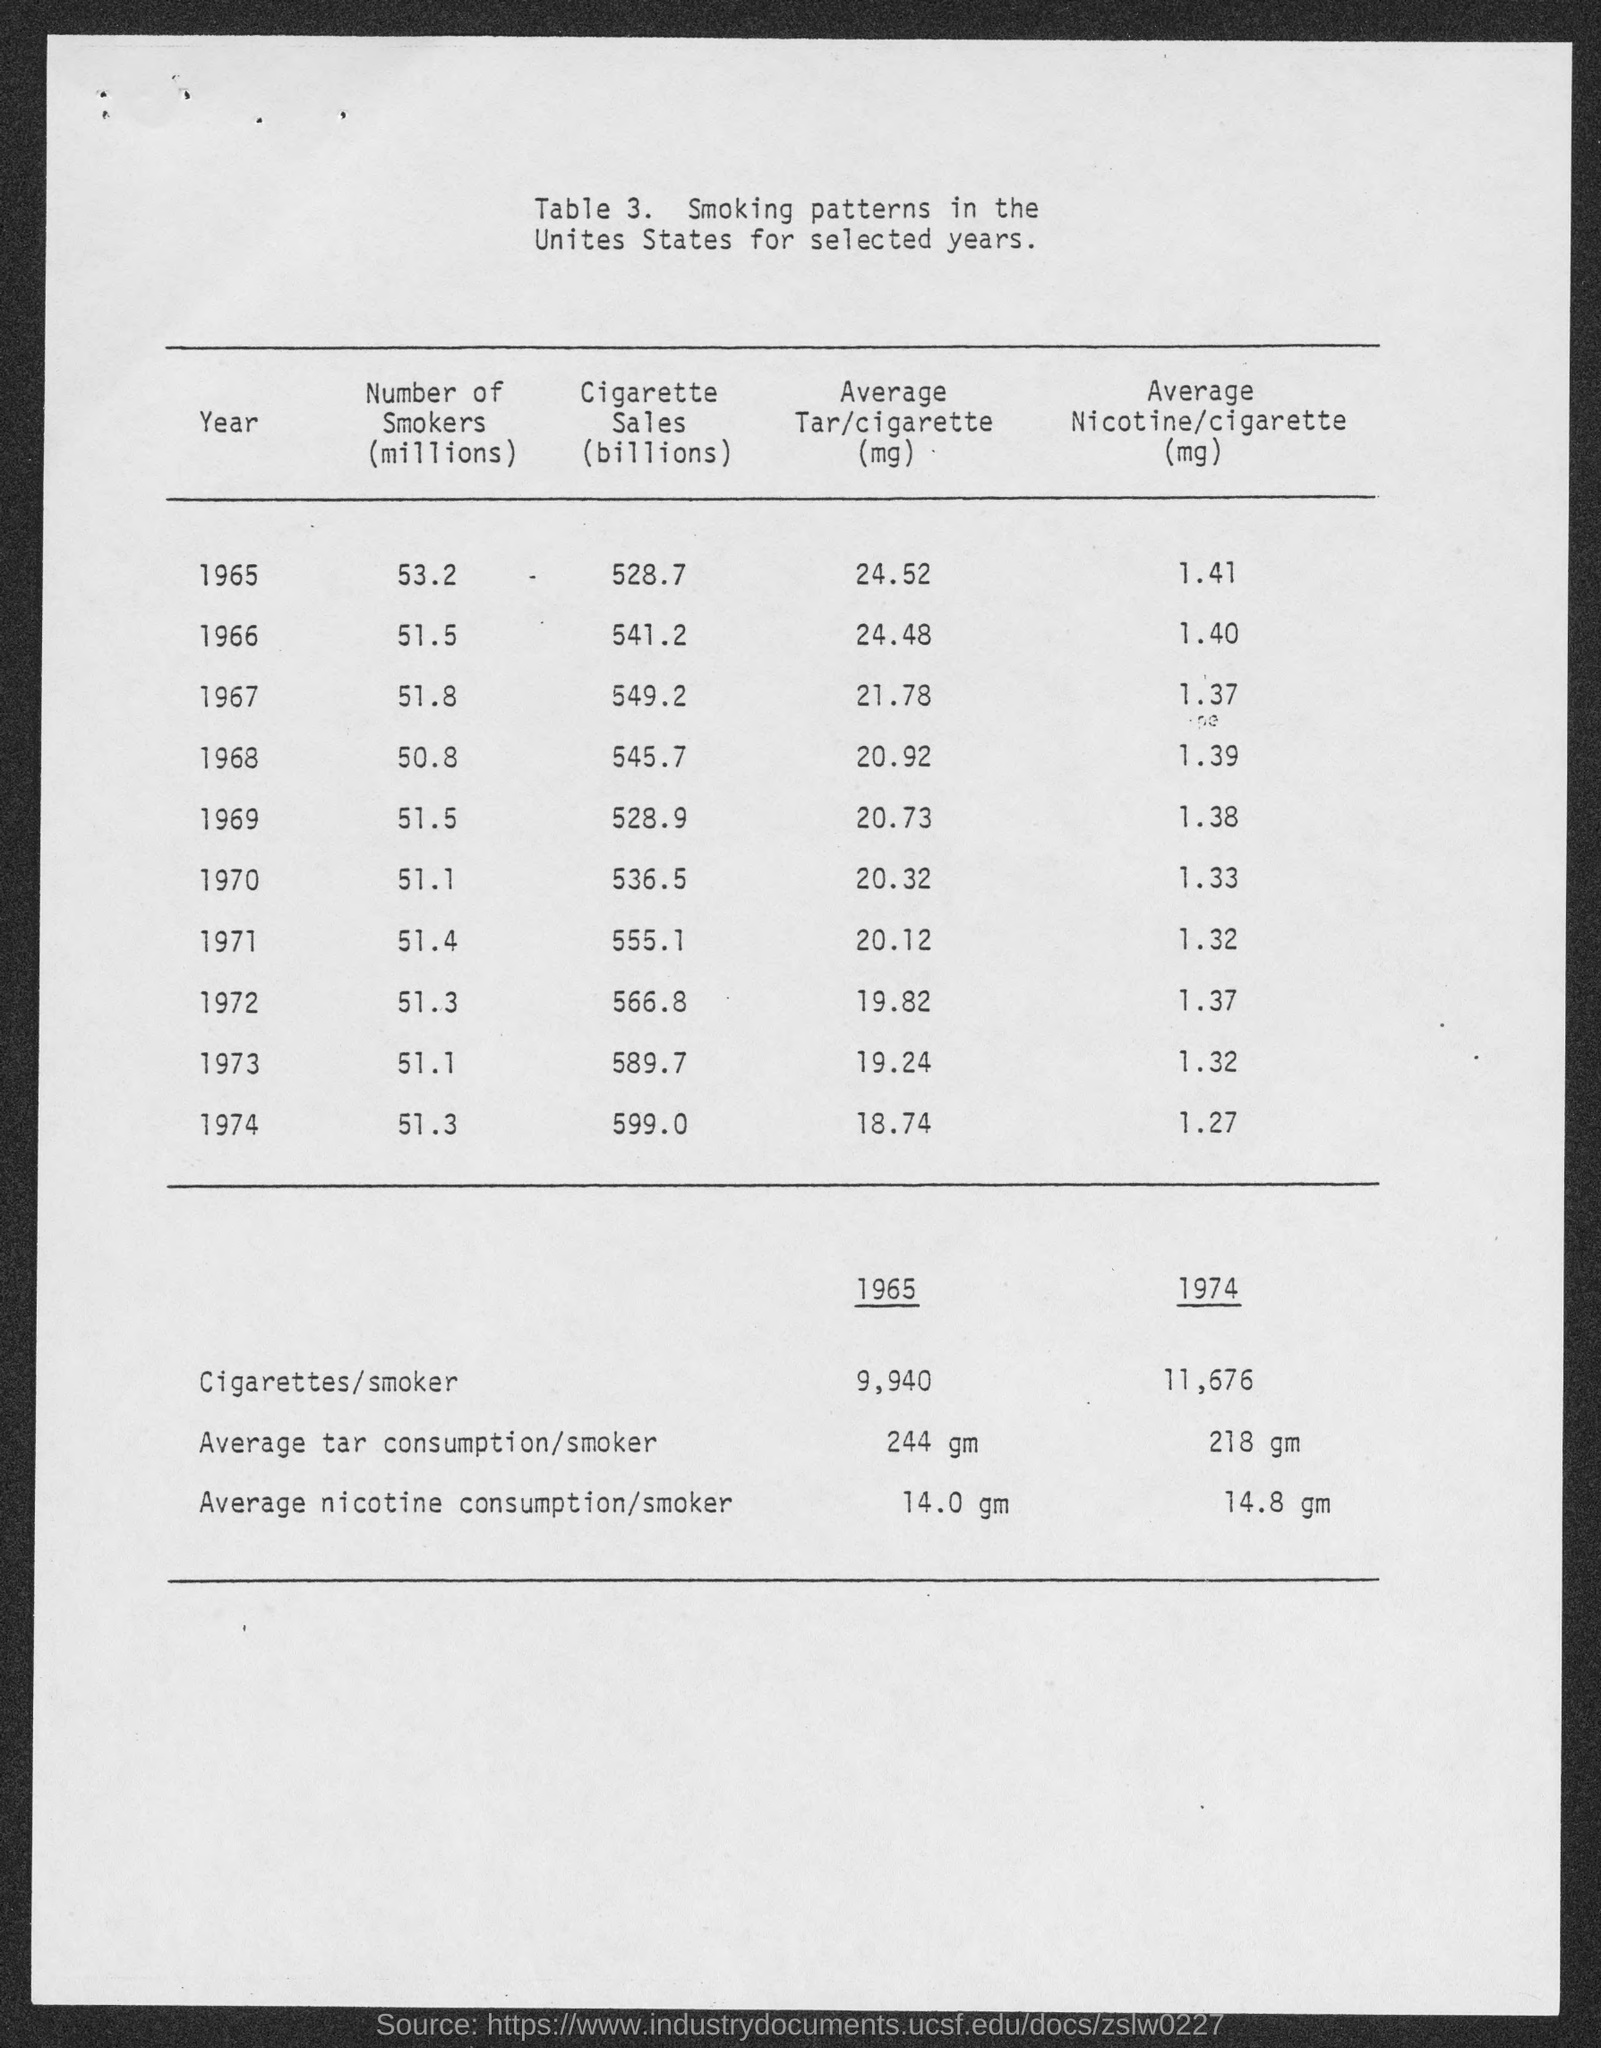What is the number of smokers (millions) in 1965?
Make the answer very short. 53.2. What is the number of smokers (millions) in 1966?
Your response must be concise. 51.5. What is the number of smokers (millions) in 1967?
Offer a terse response. 51.8. What is the number of smokers (millions) in 1968?
Ensure brevity in your answer.  50.8. What is the number of smokers (millions) in 1969?
Your response must be concise. 51.5. What is the number of smokers (millions) in 1970?
Make the answer very short. 51.1. What is the number of smokers (millions) in 1971?
Provide a short and direct response. 51.4. What is the number of smokers (millions) in 1972?
Offer a terse response. 51.3. What is the number of smokers (millions) in 1973?
Offer a very short reply. 51.1. What is the number of smokers (millions) in 1974?
Your answer should be compact. 51.3. 